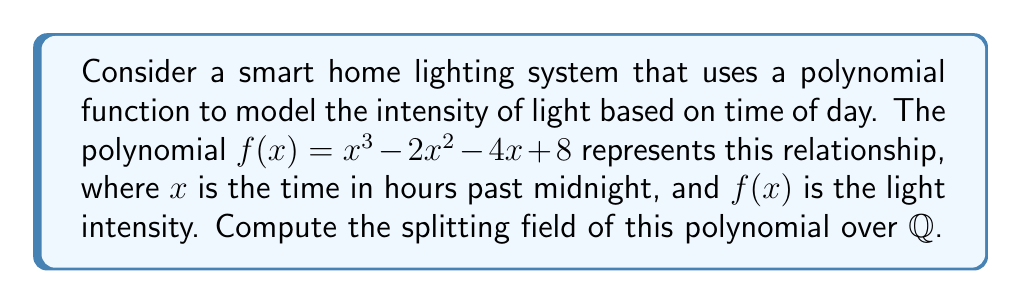Can you answer this question? To find the splitting field, we need to follow these steps:

1) First, we need to factor the polynomial $f(x) = x^3 - 2x^2 - 4x + 8$.

2) Using the rational root theorem, we can check if there are any rational roots. The possible rational roots are the factors of the constant term: $\pm 1, \pm 2, \pm 4, \pm 8$.

3) By testing these values, we find that $x = 2$ is a root of $f(x)$.

4) Dividing $f(x)$ by $(x-2)$, we get:
   $f(x) = (x-2)(x^2 + 1)$

5) The quadratic factor $x^2 + 1$ is irreducible over $\mathbb{Q}$.

6) The roots of $x^2 + 1$ are $i$ and $-i$.

7) Therefore, the splitting field of $f(x)$ over $\mathbb{Q}$ is $\mathbb{Q}(i)$, which is obtained by adjoining $i$ to $\mathbb{Q}$.

8) $\mathbb{Q}(i)$ is isomorphic to the complex numbers $\mathbb{C}$.

This splitting field allows for a complete representation of all possible light intensities in the smart home system, including both real and imaginary components, which could be interpreted as different aspects of light quality or color in a more advanced model.
Answer: $\mathbb{Q}(i)$ 